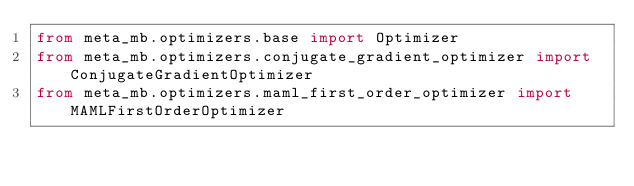Convert code to text. <code><loc_0><loc_0><loc_500><loc_500><_Python_>from meta_mb.optimizers.base import Optimizer
from meta_mb.optimizers.conjugate_gradient_optimizer import ConjugateGradientOptimizer
from meta_mb.optimizers.maml_first_order_optimizer import MAMLFirstOrderOptimizer</code> 